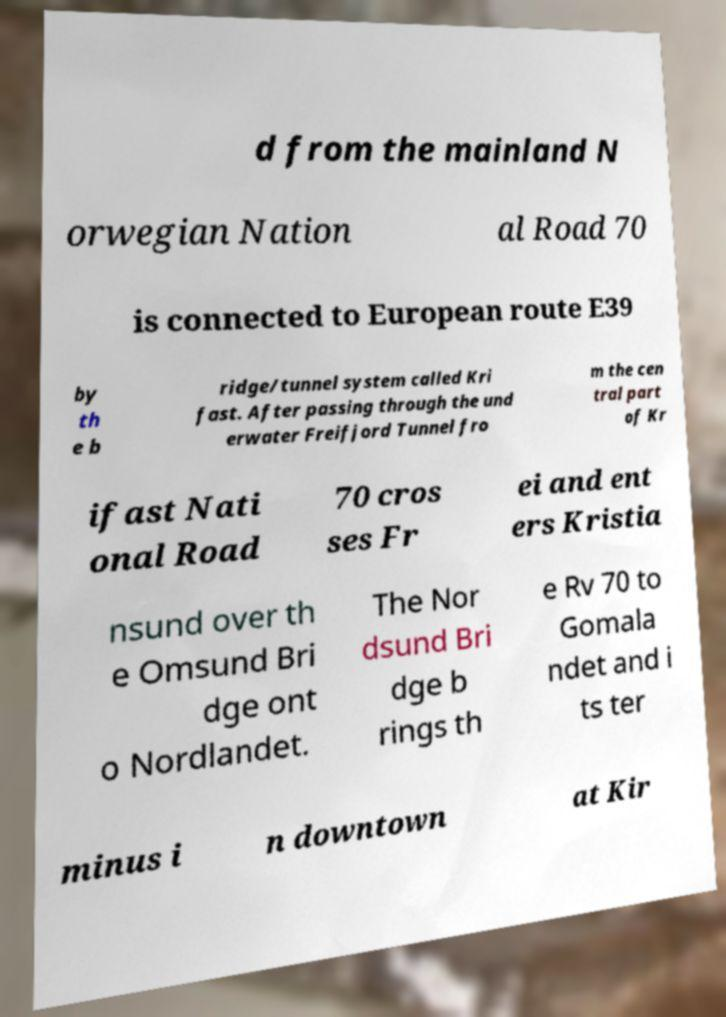What messages or text are displayed in this image? I need them in a readable, typed format. d from the mainland N orwegian Nation al Road 70 is connected to European route E39 by th e b ridge/tunnel system called Kri fast. After passing through the und erwater Freifjord Tunnel fro m the cen tral part of Kr ifast Nati onal Road 70 cros ses Fr ei and ent ers Kristia nsund over th e Omsund Bri dge ont o Nordlandet. The Nor dsund Bri dge b rings th e Rv 70 to Gomala ndet and i ts ter minus i n downtown at Kir 